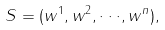Convert formula to latex. <formula><loc_0><loc_0><loc_500><loc_500>S = ( w ^ { 1 } , w ^ { 2 } , \cdot \cdot \cdot , w ^ { n } ) ,</formula> 